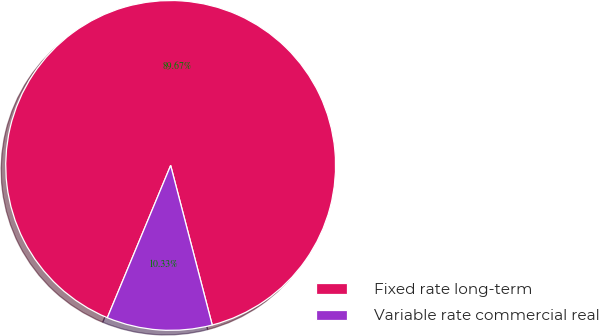Convert chart. <chart><loc_0><loc_0><loc_500><loc_500><pie_chart><fcel>Fixed rate long-term<fcel>Variable rate commercial real<nl><fcel>89.67%<fcel>10.33%<nl></chart> 